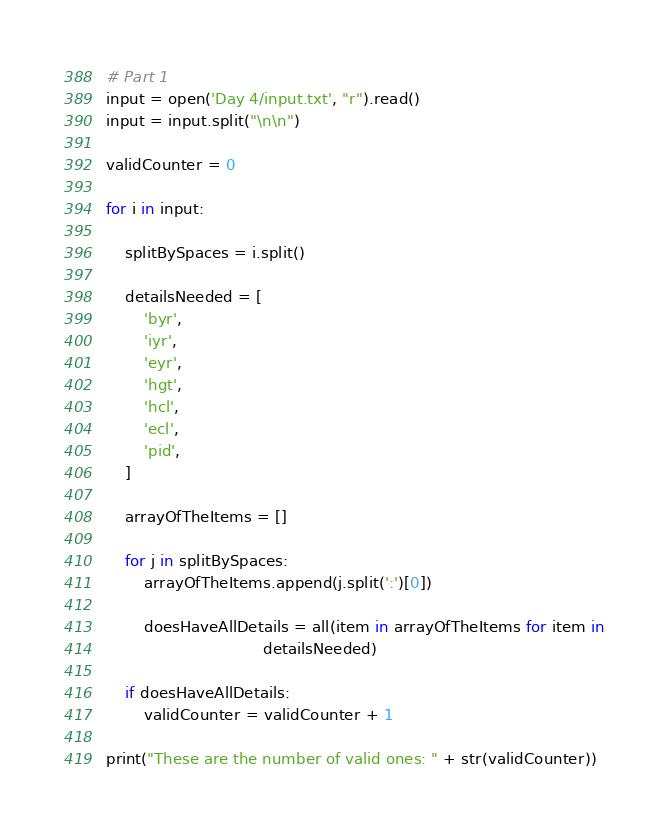<code> <loc_0><loc_0><loc_500><loc_500><_Python_># Part 1
input = open('Day 4/input.txt', "r").read()
input = input.split("\n\n")

validCounter = 0

for i in input:

    splitBySpaces = i.split()

    detailsNeeded = [
        'byr',
        'iyr',
        'eyr',
        'hgt',
        'hcl',
        'ecl',
        'pid',
    ]

    arrayOfTheItems = []

    for j in splitBySpaces:
        arrayOfTheItems.append(j.split(':')[0])

        doesHaveAllDetails = all(item in arrayOfTheItems for item in
                                 detailsNeeded)

    if doesHaveAllDetails:
        validCounter = validCounter + 1

print("These are the number of valid ones: " + str(validCounter))
</code> 